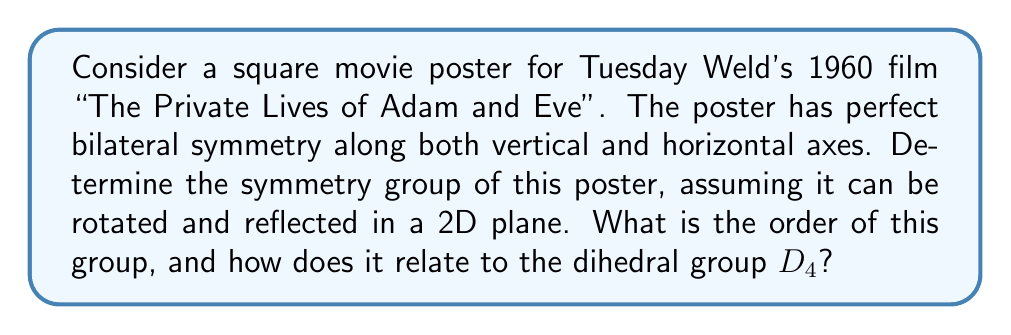Can you solve this math problem? To solve this problem, we need to consider all possible symmetry operations that leave the square poster unchanged:

1. Rotations:
   - Identity (0° rotation)
   - 90° clockwise rotation
   - 180° rotation
   - 270° clockwise rotation (or 90° counterclockwise)

2. Reflections:
   - Vertical axis reflection
   - Horizontal axis reflection
   - Diagonal reflection (top-left to bottom-right)
   - Diagonal reflection (top-right to bottom-left)

These 8 symmetry operations form a group under composition. This group is isomorphic to the dihedral group $D_4$, which is the symmetry group of a square.

The group elements can be represented as follows:
$$\{e, r, r^2, r^3, f_v, f_h, f_d, f_d'\}$$

Where:
- $e$ is the identity
- $r$ is a 90° clockwise rotation
- $f_v$ is vertical reflection
- $f_h$ is horizontal reflection
- $f_d$ and $f_d'$ are diagonal reflections

The group operation table (Cayley table) would be identical to that of $D_4$.

The order of this group is 8, as there are 8 distinct symmetry operations.

This group has the following properties:
1. It is non-abelian (rotations and reflections do not always commute)
2. It has 5 conjugacy classes
3. It has 5 subgroups, including itself and the trivial subgroup

The relationship to $D_4$ is direct: the symmetry group of this square poster is isomorphic to $D_4$. This means there is a one-to-one correspondence between the elements and operations of this group and those of $D_4$, preserving the group structure.
Answer: The symmetry group of the square movie poster is isomorphic to the dihedral group $D_4$. It has order 8 and contains 4 rotations and 4 reflections. The group can be represented as $\{e, r, r^2, r^3, f_v, f_h, f_d, f_d'\}$, where $e$ is the identity, $r$ is a 90° rotation, and $f_v$, $f_h$, $f_d$, $f_d'$ are reflections. 